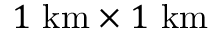<formula> <loc_0><loc_0><loc_500><loc_500>1 \ k m \times 1 \ k m</formula> 